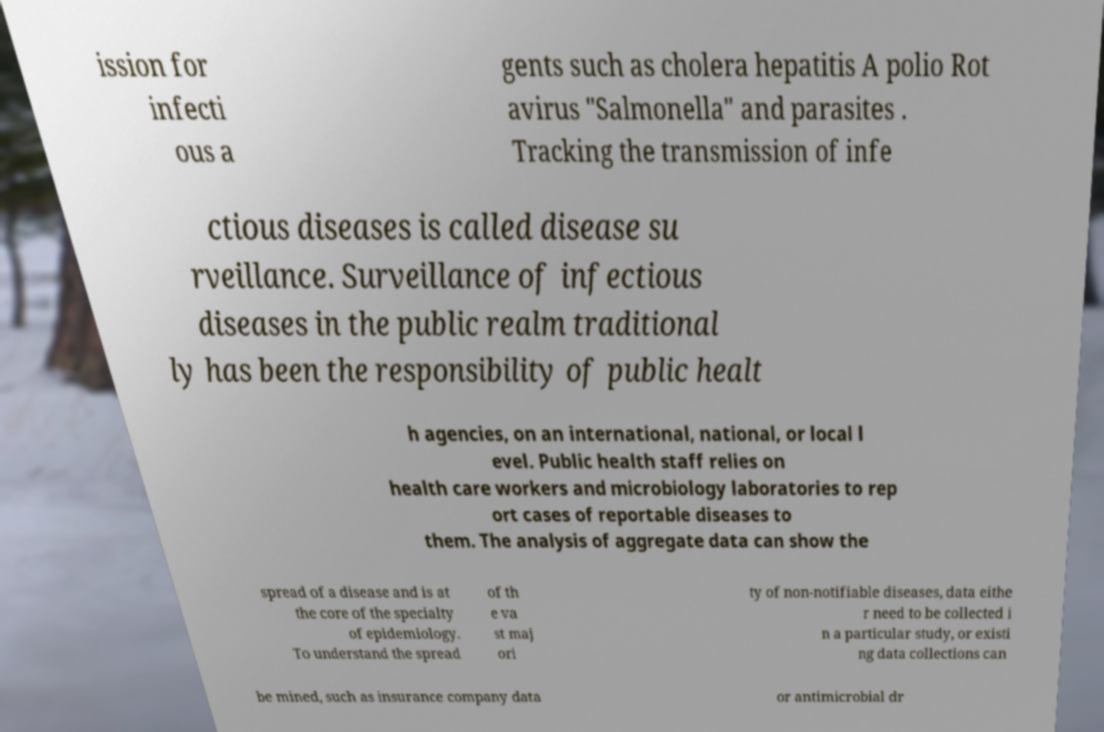Please read and relay the text visible in this image. What does it say? ission for infecti ous a gents such as cholera hepatitis A polio Rot avirus "Salmonella" and parasites . Tracking the transmission of infe ctious diseases is called disease su rveillance. Surveillance of infectious diseases in the public realm traditional ly has been the responsibility of public healt h agencies, on an international, national, or local l evel. Public health staff relies on health care workers and microbiology laboratories to rep ort cases of reportable diseases to them. The analysis of aggregate data can show the spread of a disease and is at the core of the specialty of epidemiology. To understand the spread of th e va st maj ori ty of non-notifiable diseases, data eithe r need to be collected i n a particular study, or existi ng data collections can be mined, such as insurance company data or antimicrobial dr 